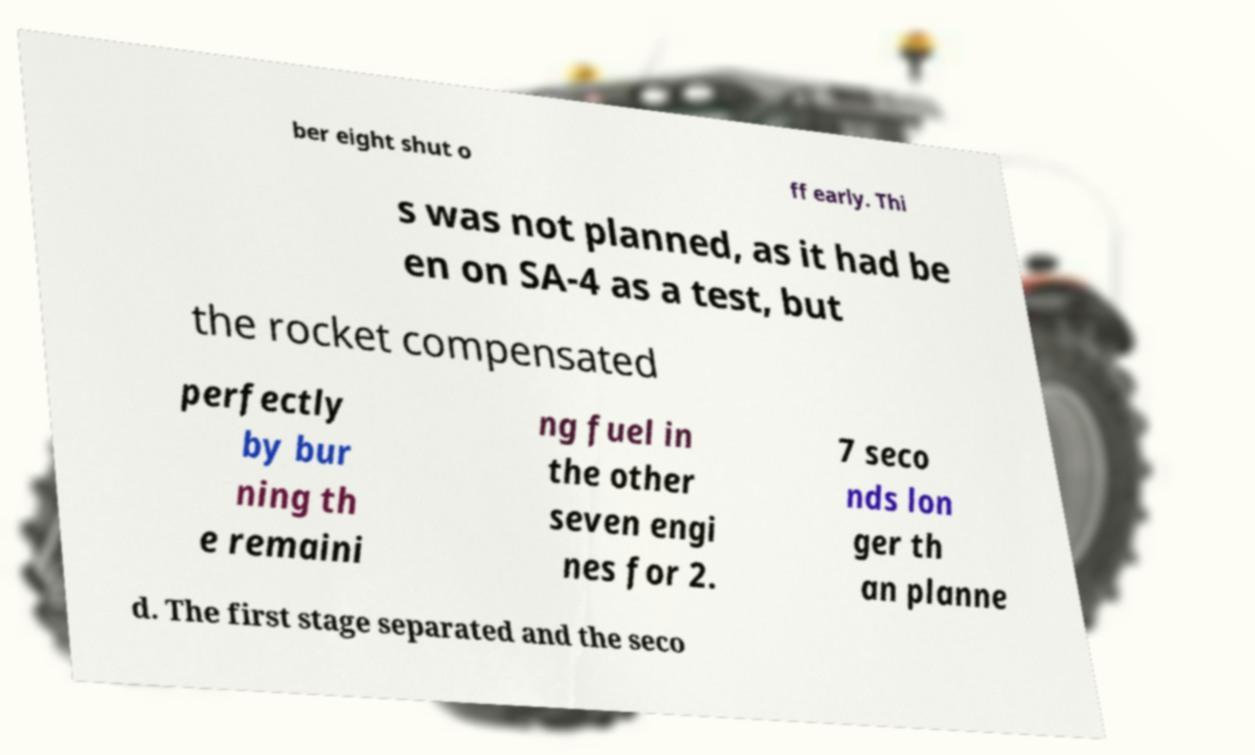For documentation purposes, I need the text within this image transcribed. Could you provide that? ber eight shut o ff early. Thi s was not planned, as it had be en on SA-4 as a test, but the rocket compensated perfectly by bur ning th e remaini ng fuel in the other seven engi nes for 2. 7 seco nds lon ger th an planne d. The first stage separated and the seco 